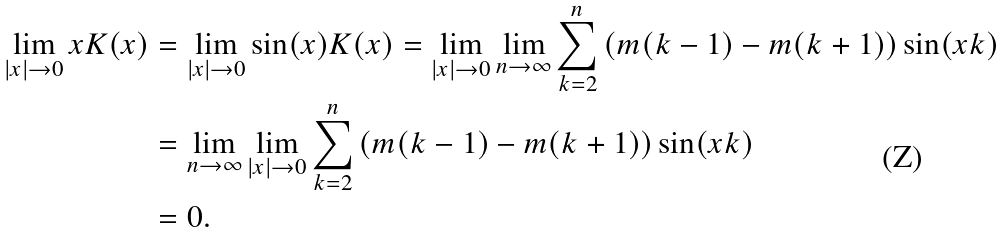<formula> <loc_0><loc_0><loc_500><loc_500>\lim _ { | x | \to 0 } x K ( x ) & = \lim _ { | x | \to 0 } \sin ( x ) K ( x ) = \lim _ { | x | \to 0 } \lim _ { n \to \infty } \sum _ { k = 2 } ^ { n } \left ( m ( k - 1 ) - m ( k + 1 ) \right ) \sin ( x k ) \\ & = \lim _ { n \to \infty } \lim _ { | x | \to 0 } \sum _ { k = 2 } ^ { n } \left ( m ( k - 1 ) - m ( k + 1 ) \right ) \sin ( x k ) \\ & = 0 .</formula> 